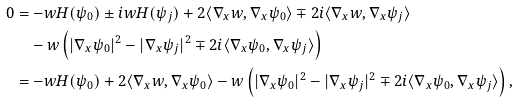<formula> <loc_0><loc_0><loc_500><loc_500>0 & = - w H ( \psi _ { 0 } ) \pm i w H ( \psi _ { j } ) + 2 \langle \nabla _ { x } w , \nabla _ { x } \psi _ { 0 } \rangle \mp 2 i \langle \nabla _ { x } w , \nabla _ { x } \psi _ { j } \rangle \\ & \quad - w \left ( | \nabla _ { x } \psi _ { 0 } | ^ { 2 } - | \nabla _ { x } \psi _ { j } | ^ { 2 } \mp 2 i \langle \nabla _ { x } \psi _ { 0 } , \nabla _ { x } \psi _ { j } \rangle \right ) \\ & = - w H ( \psi _ { 0 } ) + 2 \langle \nabla _ { x } w , \nabla _ { x } \psi _ { 0 } \rangle - w \left ( | \nabla _ { x } \psi _ { 0 } | ^ { 2 } - | \nabla _ { x } \psi _ { j } | ^ { 2 } \mp 2 i \langle \nabla _ { x } \psi _ { 0 } , \nabla _ { x } \psi _ { j } \rangle \right ) ,</formula> 